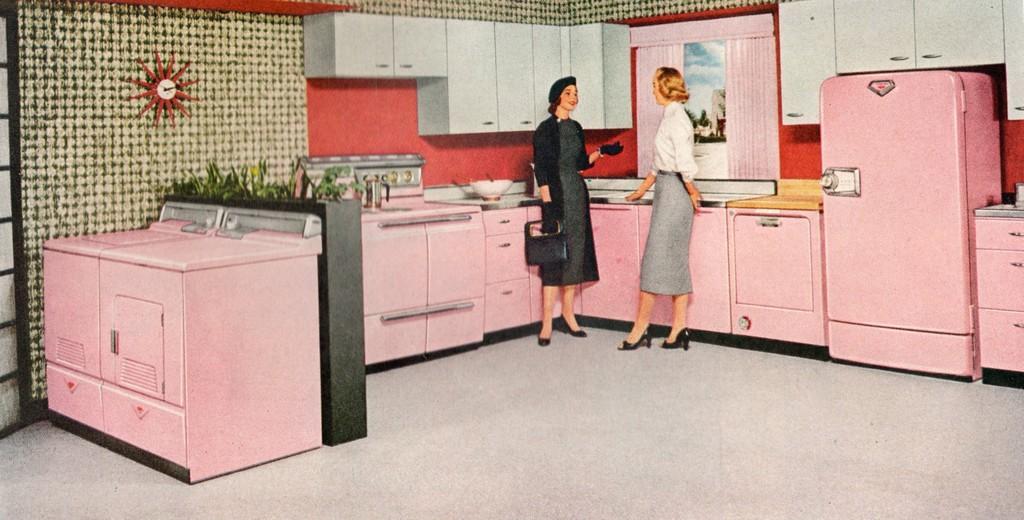Please provide a concise description of this image. In the image we can see an animated picture, in the picture we can see some household items and we can see two women standing, wearing clothes, and the left side woman is wearing gloves and carrying a bag. Here we can see the floor, cupboards and the wall. Here we can see the glass window and curtains.  